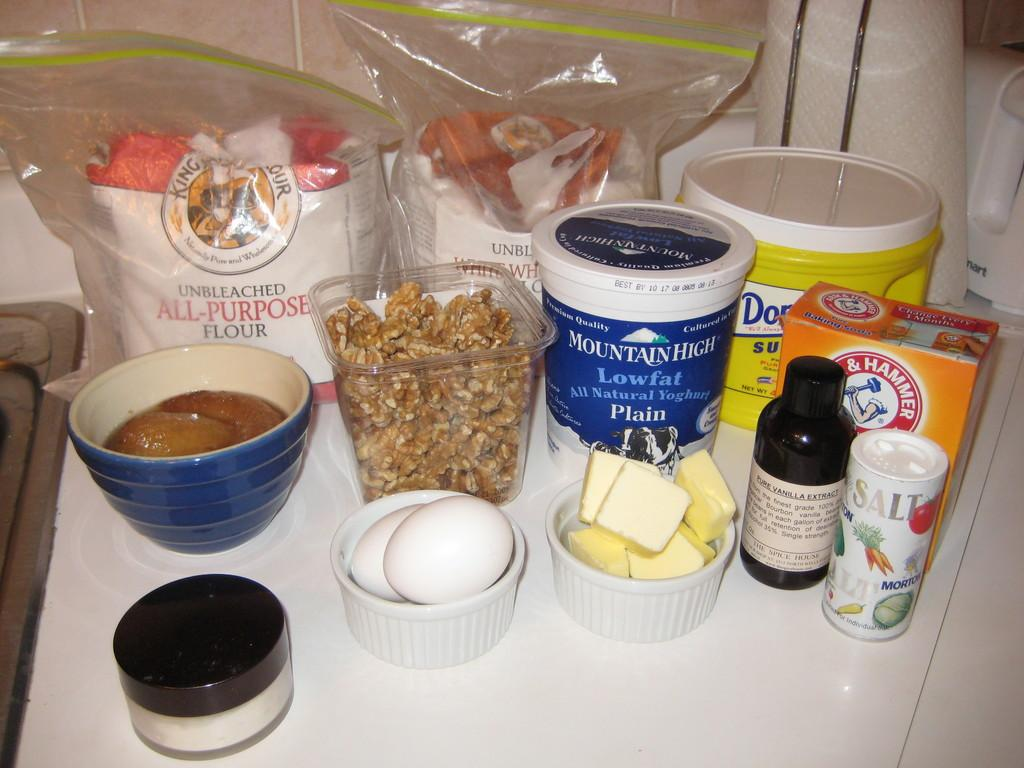<image>
Relay a brief, clear account of the picture shown. Several ingredients laid out, including eggs, butter, yogurt, and a bag of flour. 